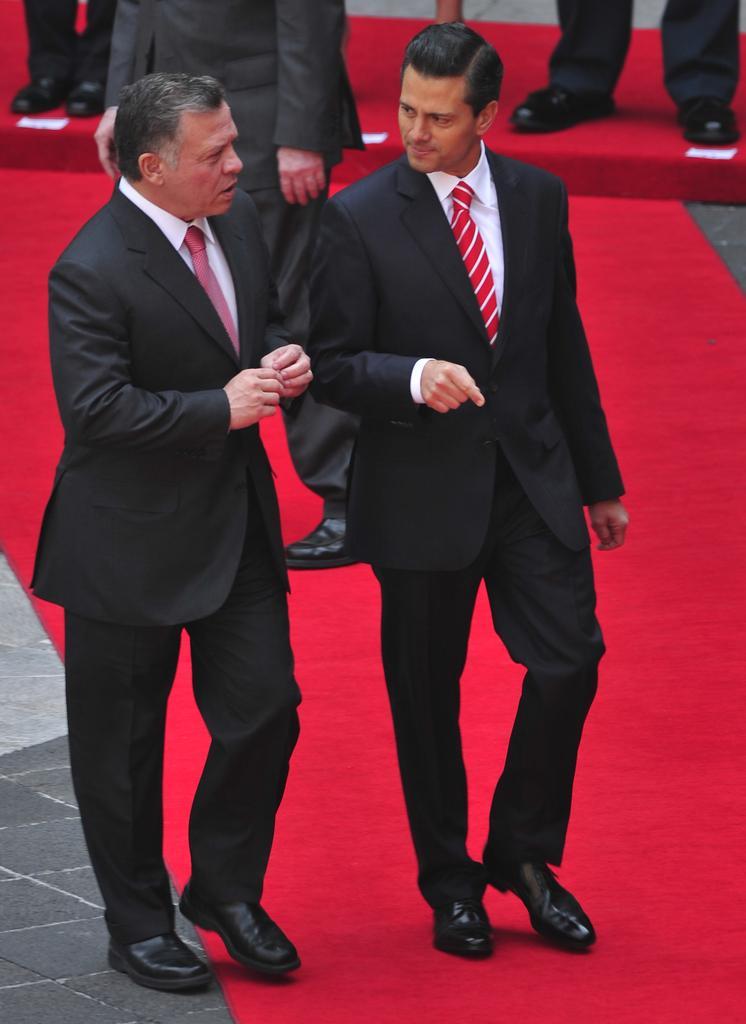Could you give a brief overview of what you see in this image? In this image, there is a red color carpet, on that there are two men standing, they are wearing black color coats, they are wearing ties, at the background there are some people standing. 